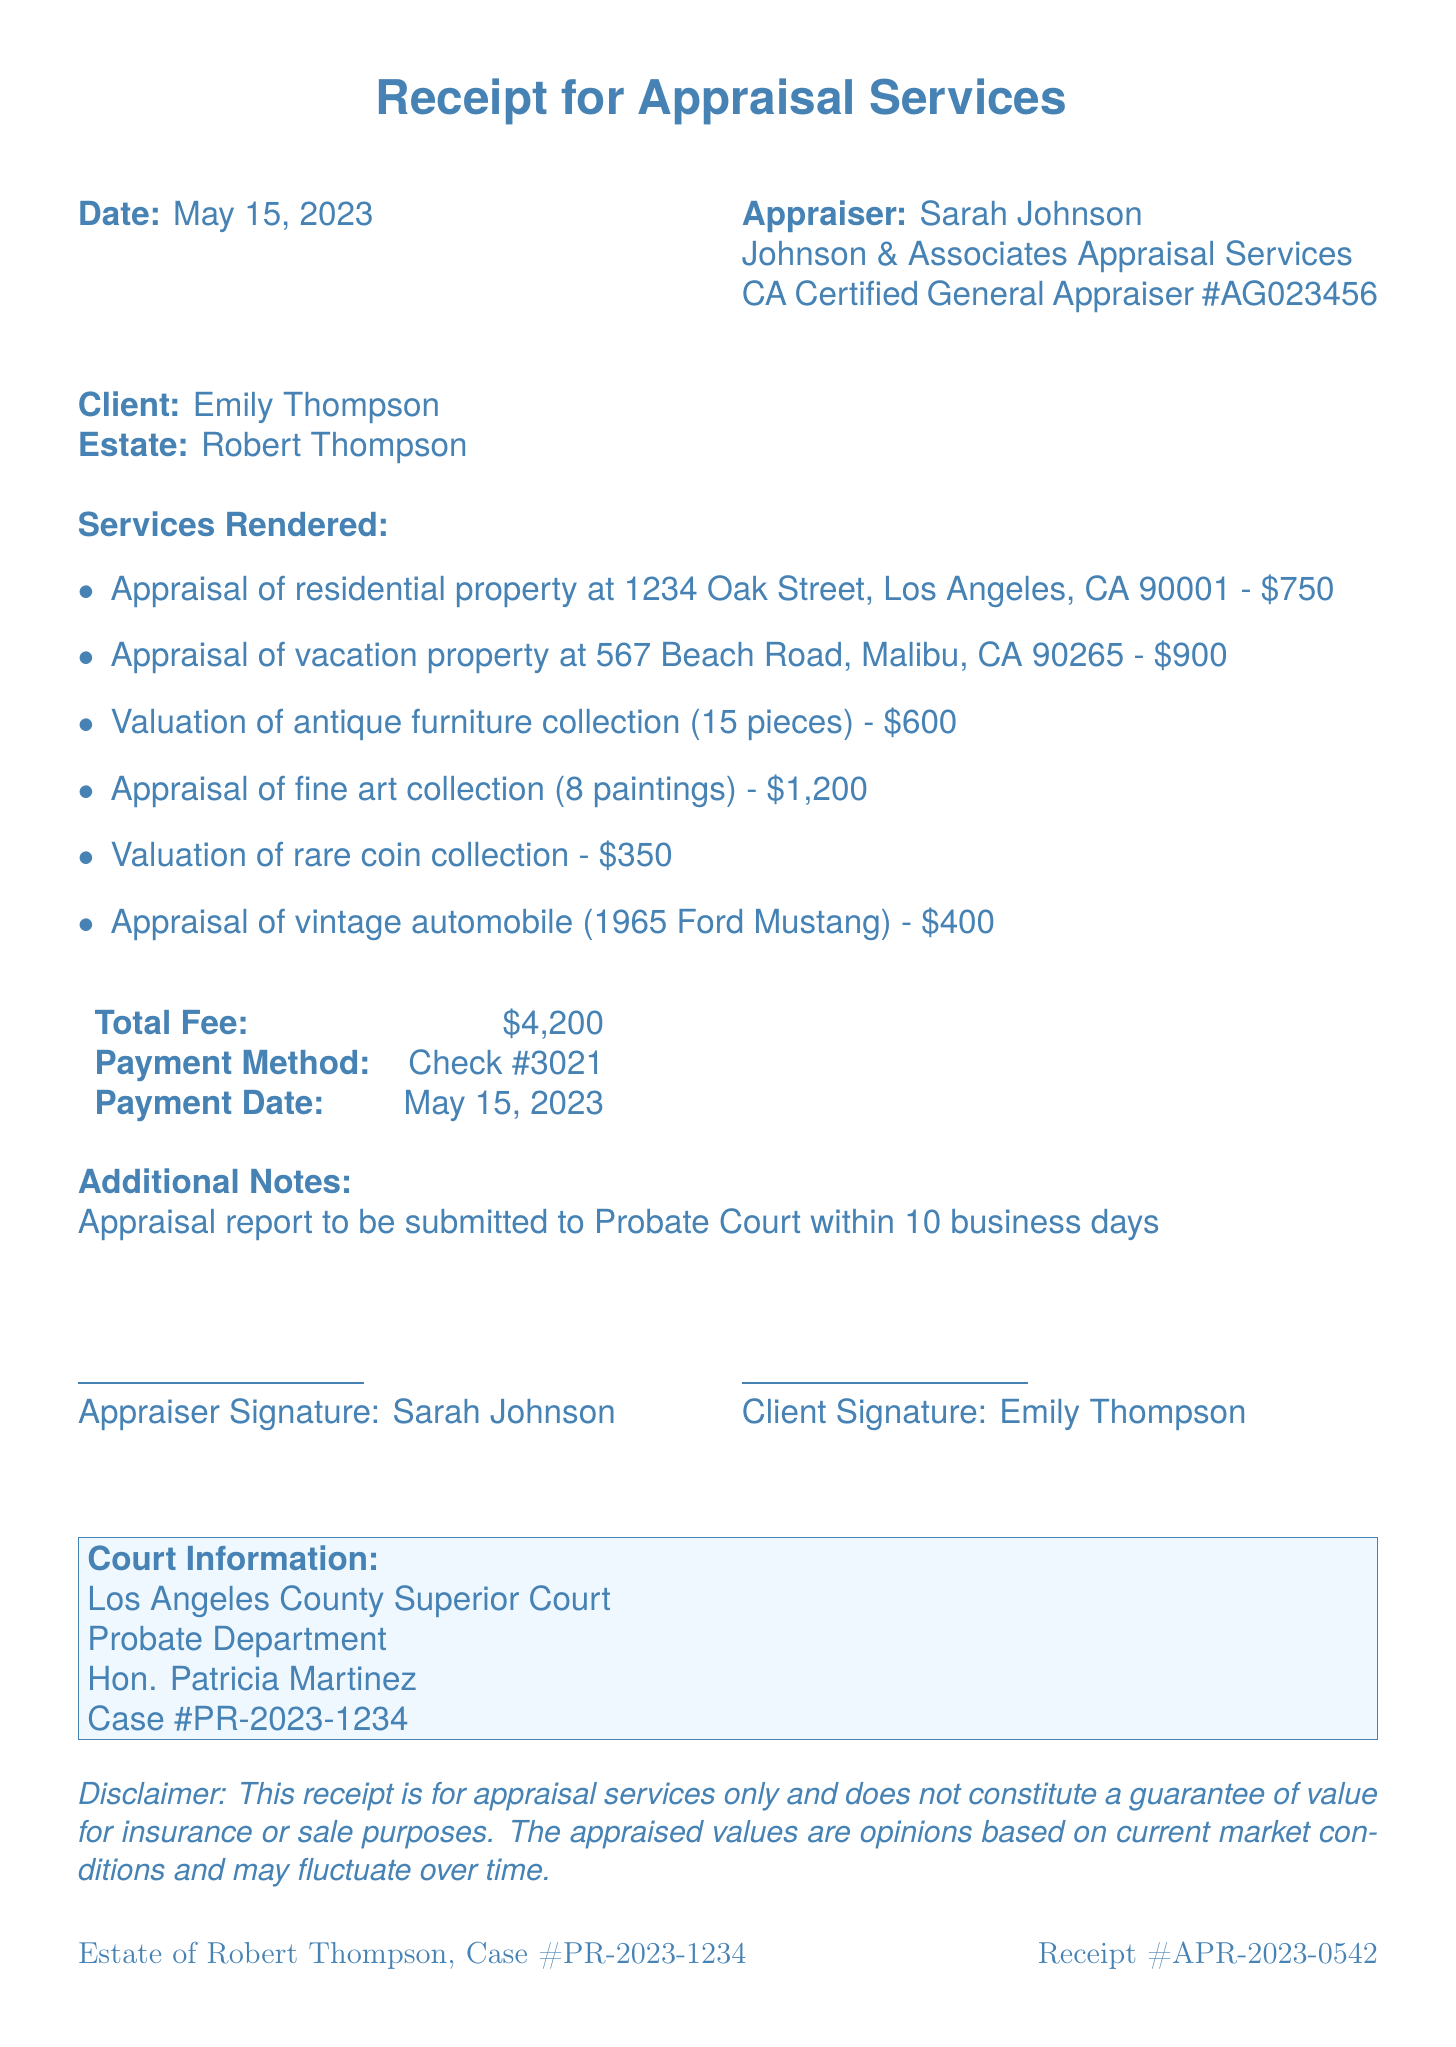What is the receipt number? The receipt number is clearly stated in the document, identifying the specific receipt for appraisal services.
Answer: APR-2023-0542 Who is the appraiser? The name of the appraiser is provided in the document as part of the appraisal services information.
Answer: Sarah Johnson What is the total fee for the appraisal services? The total fee is summarized in the document, representing the cumulative cost for all services rendered.
Answer: $4,200 How many pieces were in the antique furniture collection? The number of pieces in the antique furniture collection is specified in the valuation description of the services rendered.
Answer: 15 pieces When is the appraisal report due to be submitted to the Probate Court? The additional notes section states the timeline for when the appraisal report is to be submitted.
Answer: Within 10 business days What was the payment method used? The payment method is explicitly noted in the document, outlining how payment was processed for the services.
Answer: Check #3021 Which court is associated with this estate? The document provides specific court information related to the estate, including the name of the court.
Answer: Los Angeles County Superior Court Who signed as the client? The document includes the client's signature information, showing who represented the estate in the transaction.
Answer: Emily Thompson What is the total number of services rendered listed in the document? The document lists each individual service provided, so counting those reveals the total number.
Answer: 6 services 